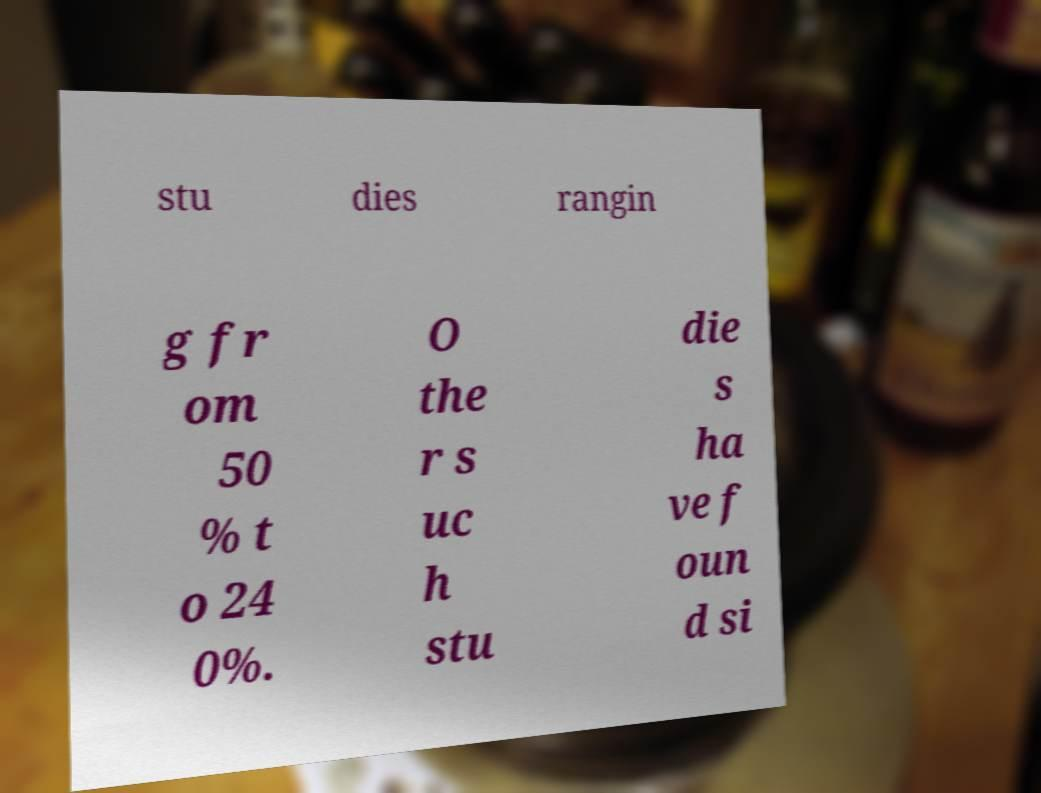What messages or text are displayed in this image? I need them in a readable, typed format. stu dies rangin g fr om 50 % t o 24 0%. O the r s uc h stu die s ha ve f oun d si 